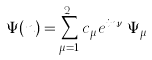<formula> <loc_0><loc_0><loc_500><loc_500>\Psi ( n ) = \sum _ { \mu = 1 } ^ { 2 ^ { q } } c _ { \mu } e ^ { i n \nu _ { \mu } } \Psi _ { \mu }</formula> 